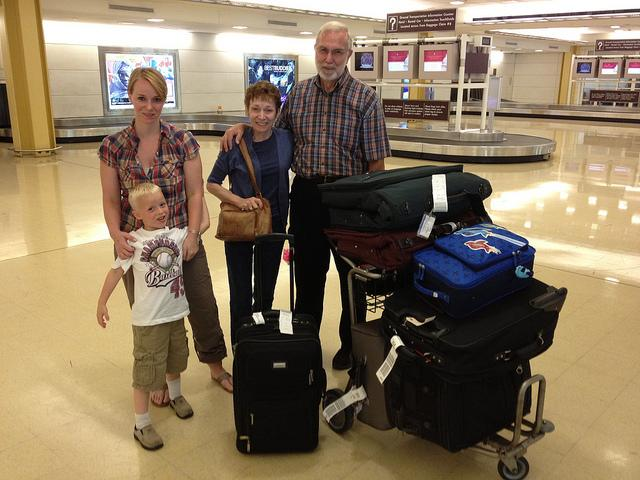What is this area for? Please explain your reasoning. claiming baggage. There is a round conveyor belt that would turn to get luggage to people. 